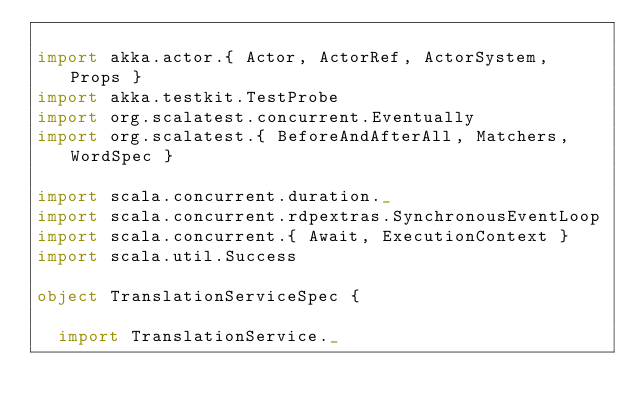<code> <loc_0><loc_0><loc_500><loc_500><_Scala_>
import akka.actor.{ Actor, ActorRef, ActorSystem, Props }
import akka.testkit.TestProbe
import org.scalatest.concurrent.Eventually
import org.scalatest.{ BeforeAndAfterAll, Matchers, WordSpec }

import scala.concurrent.duration._
import scala.concurrent.rdpextras.SynchronousEventLoop
import scala.concurrent.{ Await, ExecutionContext }
import scala.util.Success

object TranslationServiceSpec {

  import TranslationService._
</code> 